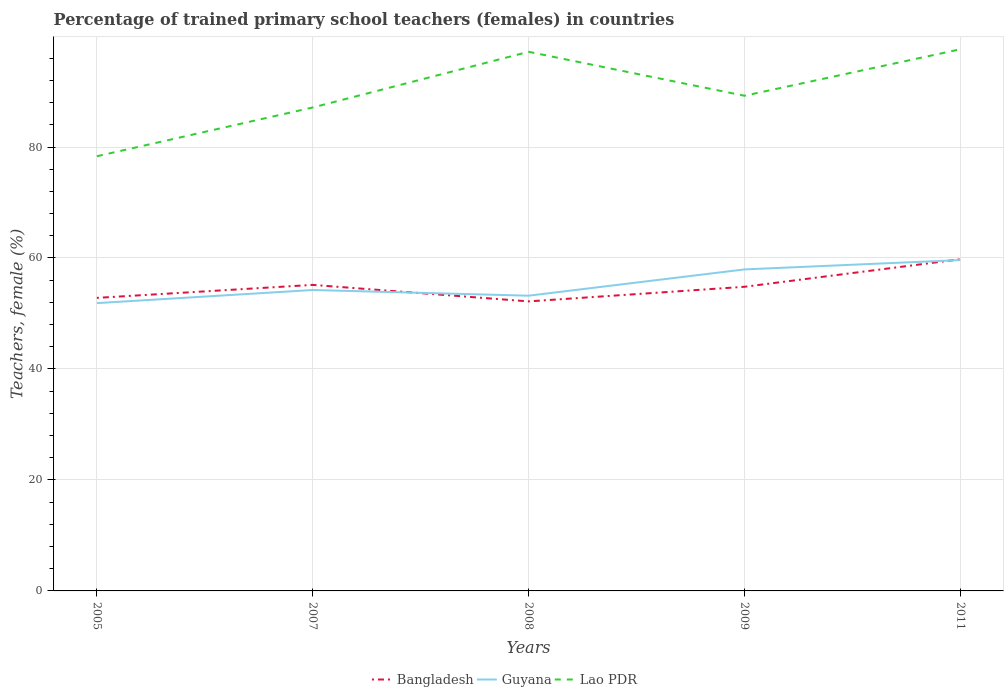Is the number of lines equal to the number of legend labels?
Your answer should be very brief. Yes. Across all years, what is the maximum percentage of trained primary school teachers (females) in Lao PDR?
Ensure brevity in your answer.  78.34. What is the total percentage of trained primary school teachers (females) in Bangladesh in the graph?
Ensure brevity in your answer.  0.64. What is the difference between the highest and the second highest percentage of trained primary school teachers (females) in Lao PDR?
Keep it short and to the point. 19.28. What is the difference between the highest and the lowest percentage of trained primary school teachers (females) in Lao PDR?
Give a very brief answer. 2. Is the percentage of trained primary school teachers (females) in Bangladesh strictly greater than the percentage of trained primary school teachers (females) in Guyana over the years?
Your answer should be compact. No. What is the difference between two consecutive major ticks on the Y-axis?
Your answer should be compact. 20. Are the values on the major ticks of Y-axis written in scientific E-notation?
Give a very brief answer. No. How many legend labels are there?
Your response must be concise. 3. What is the title of the graph?
Provide a short and direct response. Percentage of trained primary school teachers (females) in countries. Does "French Polynesia" appear as one of the legend labels in the graph?
Keep it short and to the point. No. What is the label or title of the Y-axis?
Your answer should be compact. Teachers, female (%). What is the Teachers, female (%) in Bangladesh in 2005?
Offer a very short reply. 52.81. What is the Teachers, female (%) of Guyana in 2005?
Provide a succinct answer. 51.87. What is the Teachers, female (%) of Lao PDR in 2005?
Provide a succinct answer. 78.34. What is the Teachers, female (%) in Bangladesh in 2007?
Give a very brief answer. 55.15. What is the Teachers, female (%) of Guyana in 2007?
Offer a terse response. 54.23. What is the Teachers, female (%) of Lao PDR in 2007?
Provide a short and direct response. 87.12. What is the Teachers, female (%) of Bangladesh in 2008?
Your answer should be very brief. 52.17. What is the Teachers, female (%) in Guyana in 2008?
Offer a terse response. 53.2. What is the Teachers, female (%) in Lao PDR in 2008?
Ensure brevity in your answer.  97.15. What is the Teachers, female (%) of Bangladesh in 2009?
Make the answer very short. 54.81. What is the Teachers, female (%) of Guyana in 2009?
Keep it short and to the point. 57.94. What is the Teachers, female (%) of Lao PDR in 2009?
Offer a very short reply. 89.24. What is the Teachers, female (%) in Bangladesh in 2011?
Give a very brief answer. 59.77. What is the Teachers, female (%) of Guyana in 2011?
Ensure brevity in your answer.  59.62. What is the Teachers, female (%) of Lao PDR in 2011?
Your response must be concise. 97.61. Across all years, what is the maximum Teachers, female (%) in Bangladesh?
Keep it short and to the point. 59.77. Across all years, what is the maximum Teachers, female (%) in Guyana?
Provide a short and direct response. 59.62. Across all years, what is the maximum Teachers, female (%) in Lao PDR?
Your answer should be very brief. 97.61. Across all years, what is the minimum Teachers, female (%) of Bangladesh?
Your answer should be very brief. 52.17. Across all years, what is the minimum Teachers, female (%) in Guyana?
Offer a very short reply. 51.87. Across all years, what is the minimum Teachers, female (%) of Lao PDR?
Keep it short and to the point. 78.34. What is the total Teachers, female (%) of Bangladesh in the graph?
Offer a terse response. 274.71. What is the total Teachers, female (%) of Guyana in the graph?
Give a very brief answer. 276.86. What is the total Teachers, female (%) of Lao PDR in the graph?
Offer a very short reply. 449.46. What is the difference between the Teachers, female (%) in Bangladesh in 2005 and that in 2007?
Provide a short and direct response. -2.34. What is the difference between the Teachers, female (%) of Guyana in 2005 and that in 2007?
Offer a terse response. -2.37. What is the difference between the Teachers, female (%) of Lao PDR in 2005 and that in 2007?
Provide a succinct answer. -8.79. What is the difference between the Teachers, female (%) of Bangladesh in 2005 and that in 2008?
Your response must be concise. 0.64. What is the difference between the Teachers, female (%) in Guyana in 2005 and that in 2008?
Offer a terse response. -1.34. What is the difference between the Teachers, female (%) in Lao PDR in 2005 and that in 2008?
Provide a succinct answer. -18.82. What is the difference between the Teachers, female (%) of Bangladesh in 2005 and that in 2009?
Your answer should be compact. -2. What is the difference between the Teachers, female (%) of Guyana in 2005 and that in 2009?
Your answer should be very brief. -6.07. What is the difference between the Teachers, female (%) of Lao PDR in 2005 and that in 2009?
Offer a very short reply. -10.9. What is the difference between the Teachers, female (%) of Bangladesh in 2005 and that in 2011?
Make the answer very short. -6.96. What is the difference between the Teachers, female (%) in Guyana in 2005 and that in 2011?
Provide a short and direct response. -7.76. What is the difference between the Teachers, female (%) in Lao PDR in 2005 and that in 2011?
Your answer should be very brief. -19.28. What is the difference between the Teachers, female (%) in Bangladesh in 2007 and that in 2008?
Make the answer very short. 2.98. What is the difference between the Teachers, female (%) of Guyana in 2007 and that in 2008?
Ensure brevity in your answer.  1.03. What is the difference between the Teachers, female (%) in Lao PDR in 2007 and that in 2008?
Provide a succinct answer. -10.03. What is the difference between the Teachers, female (%) in Bangladesh in 2007 and that in 2009?
Keep it short and to the point. 0.34. What is the difference between the Teachers, female (%) of Guyana in 2007 and that in 2009?
Ensure brevity in your answer.  -3.71. What is the difference between the Teachers, female (%) of Lao PDR in 2007 and that in 2009?
Your answer should be compact. -2.12. What is the difference between the Teachers, female (%) of Bangladesh in 2007 and that in 2011?
Offer a terse response. -4.62. What is the difference between the Teachers, female (%) in Guyana in 2007 and that in 2011?
Keep it short and to the point. -5.39. What is the difference between the Teachers, female (%) in Lao PDR in 2007 and that in 2011?
Your answer should be compact. -10.49. What is the difference between the Teachers, female (%) in Bangladesh in 2008 and that in 2009?
Your response must be concise. -2.63. What is the difference between the Teachers, female (%) of Guyana in 2008 and that in 2009?
Offer a terse response. -4.74. What is the difference between the Teachers, female (%) of Lao PDR in 2008 and that in 2009?
Offer a terse response. 7.91. What is the difference between the Teachers, female (%) of Bangladesh in 2008 and that in 2011?
Offer a very short reply. -7.59. What is the difference between the Teachers, female (%) in Guyana in 2008 and that in 2011?
Provide a short and direct response. -6.42. What is the difference between the Teachers, female (%) of Lao PDR in 2008 and that in 2011?
Your answer should be compact. -0.46. What is the difference between the Teachers, female (%) of Bangladesh in 2009 and that in 2011?
Provide a succinct answer. -4.96. What is the difference between the Teachers, female (%) in Guyana in 2009 and that in 2011?
Keep it short and to the point. -1.68. What is the difference between the Teachers, female (%) of Lao PDR in 2009 and that in 2011?
Your answer should be compact. -8.37. What is the difference between the Teachers, female (%) of Bangladesh in 2005 and the Teachers, female (%) of Guyana in 2007?
Give a very brief answer. -1.42. What is the difference between the Teachers, female (%) in Bangladesh in 2005 and the Teachers, female (%) in Lao PDR in 2007?
Provide a short and direct response. -34.31. What is the difference between the Teachers, female (%) of Guyana in 2005 and the Teachers, female (%) of Lao PDR in 2007?
Offer a terse response. -35.26. What is the difference between the Teachers, female (%) of Bangladesh in 2005 and the Teachers, female (%) of Guyana in 2008?
Your response must be concise. -0.39. What is the difference between the Teachers, female (%) in Bangladesh in 2005 and the Teachers, female (%) in Lao PDR in 2008?
Your answer should be very brief. -44.34. What is the difference between the Teachers, female (%) in Guyana in 2005 and the Teachers, female (%) in Lao PDR in 2008?
Offer a terse response. -45.29. What is the difference between the Teachers, female (%) in Bangladesh in 2005 and the Teachers, female (%) in Guyana in 2009?
Ensure brevity in your answer.  -5.13. What is the difference between the Teachers, female (%) of Bangladesh in 2005 and the Teachers, female (%) of Lao PDR in 2009?
Give a very brief answer. -36.43. What is the difference between the Teachers, female (%) of Guyana in 2005 and the Teachers, female (%) of Lao PDR in 2009?
Provide a succinct answer. -37.37. What is the difference between the Teachers, female (%) of Bangladesh in 2005 and the Teachers, female (%) of Guyana in 2011?
Offer a terse response. -6.81. What is the difference between the Teachers, female (%) of Bangladesh in 2005 and the Teachers, female (%) of Lao PDR in 2011?
Provide a succinct answer. -44.8. What is the difference between the Teachers, female (%) of Guyana in 2005 and the Teachers, female (%) of Lao PDR in 2011?
Your answer should be very brief. -45.75. What is the difference between the Teachers, female (%) of Bangladesh in 2007 and the Teachers, female (%) of Guyana in 2008?
Provide a succinct answer. 1.95. What is the difference between the Teachers, female (%) in Bangladesh in 2007 and the Teachers, female (%) in Lao PDR in 2008?
Offer a very short reply. -42. What is the difference between the Teachers, female (%) in Guyana in 2007 and the Teachers, female (%) in Lao PDR in 2008?
Make the answer very short. -42.92. What is the difference between the Teachers, female (%) of Bangladesh in 2007 and the Teachers, female (%) of Guyana in 2009?
Keep it short and to the point. -2.79. What is the difference between the Teachers, female (%) in Bangladesh in 2007 and the Teachers, female (%) in Lao PDR in 2009?
Offer a very short reply. -34.09. What is the difference between the Teachers, female (%) in Guyana in 2007 and the Teachers, female (%) in Lao PDR in 2009?
Ensure brevity in your answer.  -35.01. What is the difference between the Teachers, female (%) in Bangladesh in 2007 and the Teachers, female (%) in Guyana in 2011?
Give a very brief answer. -4.47. What is the difference between the Teachers, female (%) in Bangladesh in 2007 and the Teachers, female (%) in Lao PDR in 2011?
Provide a short and direct response. -42.46. What is the difference between the Teachers, female (%) of Guyana in 2007 and the Teachers, female (%) of Lao PDR in 2011?
Your response must be concise. -43.38. What is the difference between the Teachers, female (%) of Bangladesh in 2008 and the Teachers, female (%) of Guyana in 2009?
Offer a very short reply. -5.76. What is the difference between the Teachers, female (%) of Bangladesh in 2008 and the Teachers, female (%) of Lao PDR in 2009?
Give a very brief answer. -37.06. What is the difference between the Teachers, female (%) of Guyana in 2008 and the Teachers, female (%) of Lao PDR in 2009?
Your response must be concise. -36.03. What is the difference between the Teachers, female (%) of Bangladesh in 2008 and the Teachers, female (%) of Guyana in 2011?
Your answer should be compact. -7.45. What is the difference between the Teachers, female (%) in Bangladesh in 2008 and the Teachers, female (%) in Lao PDR in 2011?
Offer a very short reply. -45.44. What is the difference between the Teachers, female (%) of Guyana in 2008 and the Teachers, female (%) of Lao PDR in 2011?
Ensure brevity in your answer.  -44.41. What is the difference between the Teachers, female (%) in Bangladesh in 2009 and the Teachers, female (%) in Guyana in 2011?
Provide a short and direct response. -4.81. What is the difference between the Teachers, female (%) of Bangladesh in 2009 and the Teachers, female (%) of Lao PDR in 2011?
Offer a very short reply. -42.8. What is the difference between the Teachers, female (%) of Guyana in 2009 and the Teachers, female (%) of Lao PDR in 2011?
Your answer should be very brief. -39.67. What is the average Teachers, female (%) in Bangladesh per year?
Provide a short and direct response. 54.94. What is the average Teachers, female (%) of Guyana per year?
Your response must be concise. 55.37. What is the average Teachers, female (%) in Lao PDR per year?
Offer a very short reply. 89.89. In the year 2005, what is the difference between the Teachers, female (%) of Bangladesh and Teachers, female (%) of Guyana?
Make the answer very short. 0.95. In the year 2005, what is the difference between the Teachers, female (%) in Bangladesh and Teachers, female (%) in Lao PDR?
Offer a very short reply. -25.53. In the year 2005, what is the difference between the Teachers, female (%) of Guyana and Teachers, female (%) of Lao PDR?
Keep it short and to the point. -26.47. In the year 2007, what is the difference between the Teachers, female (%) of Bangladesh and Teachers, female (%) of Guyana?
Offer a terse response. 0.92. In the year 2007, what is the difference between the Teachers, female (%) of Bangladesh and Teachers, female (%) of Lao PDR?
Offer a very short reply. -31.97. In the year 2007, what is the difference between the Teachers, female (%) of Guyana and Teachers, female (%) of Lao PDR?
Your answer should be very brief. -32.89. In the year 2008, what is the difference between the Teachers, female (%) of Bangladesh and Teachers, female (%) of Guyana?
Ensure brevity in your answer.  -1.03. In the year 2008, what is the difference between the Teachers, female (%) in Bangladesh and Teachers, female (%) in Lao PDR?
Provide a succinct answer. -44.98. In the year 2008, what is the difference between the Teachers, female (%) of Guyana and Teachers, female (%) of Lao PDR?
Provide a succinct answer. -43.95. In the year 2009, what is the difference between the Teachers, female (%) of Bangladesh and Teachers, female (%) of Guyana?
Your answer should be compact. -3.13. In the year 2009, what is the difference between the Teachers, female (%) of Bangladesh and Teachers, female (%) of Lao PDR?
Make the answer very short. -34.43. In the year 2009, what is the difference between the Teachers, female (%) of Guyana and Teachers, female (%) of Lao PDR?
Your answer should be compact. -31.3. In the year 2011, what is the difference between the Teachers, female (%) in Bangladesh and Teachers, female (%) in Guyana?
Offer a terse response. 0.14. In the year 2011, what is the difference between the Teachers, female (%) in Bangladesh and Teachers, female (%) in Lao PDR?
Ensure brevity in your answer.  -37.84. In the year 2011, what is the difference between the Teachers, female (%) in Guyana and Teachers, female (%) in Lao PDR?
Keep it short and to the point. -37.99. What is the ratio of the Teachers, female (%) in Bangladesh in 2005 to that in 2007?
Your answer should be very brief. 0.96. What is the ratio of the Teachers, female (%) in Guyana in 2005 to that in 2007?
Your response must be concise. 0.96. What is the ratio of the Teachers, female (%) of Lao PDR in 2005 to that in 2007?
Your answer should be very brief. 0.9. What is the ratio of the Teachers, female (%) of Bangladesh in 2005 to that in 2008?
Provide a short and direct response. 1.01. What is the ratio of the Teachers, female (%) in Guyana in 2005 to that in 2008?
Your response must be concise. 0.97. What is the ratio of the Teachers, female (%) of Lao PDR in 2005 to that in 2008?
Make the answer very short. 0.81. What is the ratio of the Teachers, female (%) of Bangladesh in 2005 to that in 2009?
Ensure brevity in your answer.  0.96. What is the ratio of the Teachers, female (%) in Guyana in 2005 to that in 2009?
Make the answer very short. 0.9. What is the ratio of the Teachers, female (%) in Lao PDR in 2005 to that in 2009?
Provide a short and direct response. 0.88. What is the ratio of the Teachers, female (%) in Bangladesh in 2005 to that in 2011?
Provide a short and direct response. 0.88. What is the ratio of the Teachers, female (%) of Guyana in 2005 to that in 2011?
Offer a terse response. 0.87. What is the ratio of the Teachers, female (%) of Lao PDR in 2005 to that in 2011?
Offer a terse response. 0.8. What is the ratio of the Teachers, female (%) in Bangladesh in 2007 to that in 2008?
Give a very brief answer. 1.06. What is the ratio of the Teachers, female (%) in Guyana in 2007 to that in 2008?
Give a very brief answer. 1.02. What is the ratio of the Teachers, female (%) in Lao PDR in 2007 to that in 2008?
Offer a terse response. 0.9. What is the ratio of the Teachers, female (%) in Bangladesh in 2007 to that in 2009?
Offer a very short reply. 1.01. What is the ratio of the Teachers, female (%) of Guyana in 2007 to that in 2009?
Your answer should be compact. 0.94. What is the ratio of the Teachers, female (%) of Lao PDR in 2007 to that in 2009?
Keep it short and to the point. 0.98. What is the ratio of the Teachers, female (%) in Bangladesh in 2007 to that in 2011?
Ensure brevity in your answer.  0.92. What is the ratio of the Teachers, female (%) in Guyana in 2007 to that in 2011?
Provide a short and direct response. 0.91. What is the ratio of the Teachers, female (%) of Lao PDR in 2007 to that in 2011?
Your answer should be compact. 0.89. What is the ratio of the Teachers, female (%) of Bangladesh in 2008 to that in 2009?
Keep it short and to the point. 0.95. What is the ratio of the Teachers, female (%) in Guyana in 2008 to that in 2009?
Offer a very short reply. 0.92. What is the ratio of the Teachers, female (%) of Lao PDR in 2008 to that in 2009?
Provide a succinct answer. 1.09. What is the ratio of the Teachers, female (%) in Bangladesh in 2008 to that in 2011?
Offer a terse response. 0.87. What is the ratio of the Teachers, female (%) in Guyana in 2008 to that in 2011?
Ensure brevity in your answer.  0.89. What is the ratio of the Teachers, female (%) in Bangladesh in 2009 to that in 2011?
Your response must be concise. 0.92. What is the ratio of the Teachers, female (%) in Guyana in 2009 to that in 2011?
Ensure brevity in your answer.  0.97. What is the ratio of the Teachers, female (%) of Lao PDR in 2009 to that in 2011?
Your response must be concise. 0.91. What is the difference between the highest and the second highest Teachers, female (%) in Bangladesh?
Provide a short and direct response. 4.62. What is the difference between the highest and the second highest Teachers, female (%) in Guyana?
Provide a short and direct response. 1.68. What is the difference between the highest and the second highest Teachers, female (%) of Lao PDR?
Your answer should be compact. 0.46. What is the difference between the highest and the lowest Teachers, female (%) in Bangladesh?
Ensure brevity in your answer.  7.59. What is the difference between the highest and the lowest Teachers, female (%) in Guyana?
Offer a very short reply. 7.76. What is the difference between the highest and the lowest Teachers, female (%) in Lao PDR?
Your answer should be very brief. 19.28. 